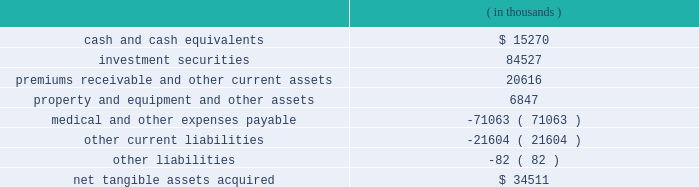Humana inc .
Notes to consolidated financial statements 2014 ( continued ) in any spe transactions .
The adoption of fin 46 or fin 46-r did not have a material impact on our financial position , results of operations , or cash flows .
In december 2004 , the fasb issued statement no .
123r , share-based payment , or statement 123r , which requires companies to expense the fair value of employee stock options and other forms of stock-based compensation .
This requirement represents a significant change because fixed-based stock option awards , a predominate form of stock compensation for us , were not recognized as compensation expense under apb 25 .
Statement 123r requires the cost of the award , as determined on the date of grant at fair value , be recognized over the period during which an employee is required to provide service in exchange for the award ( usually the vesting period ) .
The grant-date fair value of the award will be estimated using option-pricing models .
We are required to adopt statement 123r no later than july 1 , 2005 under one of three transition methods , including a prospective , retrospective and combination approach .
We previously disclosed on page 67 the effect of expensing stock options under a fair value approach using the black-scholes pricing model for 2004 , 2003 and 2002 .
We currently are evaluating all of the provisions of statement 123r and the expected effect on us including , among other items , reviewing compensation strategies related to stock-based awards , selecting an option pricing model and determining the transition method .
In march 2004 , the fasb issued eitf issue no .
03-1 , or eitf 03-1 , the meaning of other-than- temporary impairment and its application to certain investments .
Eitf 03-1 includes new guidance for evaluating and recording impairment losses on certain debt and equity investments when the fair value of the investment security is less than its carrying value .
In september 2004 , the fasb delayed the previously scheduled third quarter 2004 effective date until the issuance of additional implementation guidance , expected in 2005 .
Upon issuance of a final standard , we will evaluate the impact on our consolidated financial position and results of operations .
Acquisitions on february 16 , 2005 , we acquired careplus health plans of florida , or careplus , as well as its affiliated 10 medical centers and pharmacy company .
Careplus provides medicare advantage hmo plans and benefits to medicare eligible members in miami-dade , broward and palm beach counties .
This acquisition enhances our medicare market position in south florida .
We paid approximately $ 450 million in cash including estimated transaction costs , subject to a balance sheet settlement process with a nine month claims run-out period .
We currently are in the process of allocating the purchase price to the net tangible and intangible assets .
On april 1 , 2004 , we acquired ochsner health plan , or ochsner , from the ochsner clinic foundation .
Ochsner is a louisiana health benefits company offering network-based managed care plans to employer-groups and medicare eligible members .
This acquisition enabled us to enter a new market with significant market share which should facilitate new sales opportunities in this and surrounding markets , including houston , texas .
We paid $ 157.1 million in cash , including transaction costs .
The fair value of the tangible assets ( liabilities ) as of the acquisition date are as follows: .

What is the percentage of property and equipment and other assets among the total assets? 
Rationale: it is the value of property and equipment and other assets divided by the total assets , then turned into a percentage .
Computations: (6847 / ((15270 + 84527) + (20616 + 6847)))
Answer: 0.0538. 